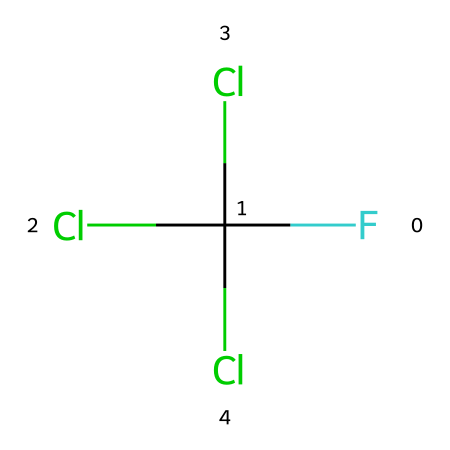What is the total number of chlorine atoms in this molecule? The given SMILES shows three chlorine atoms represented by 'Cl' in the composition. By counting the occurrences, we find three chlorine atoms present.
Answer: three How many fluorine atoms are present in this chemical? In the SMILES notation, there is one occurrence of 'F', indicating that there is one fluorine atom in this compound.
Answer: one What type of chemical is represented by this structure? The presence of fluorine and chlorine atoms, along with a carbon atom suggests this molecule is a chlorofluorocarbon, commonly known as CFC.
Answer: chlorofluorocarbon What is the valency of carbon in this molecule? Carbon typically has four valence electrons and forms four bonds, and in this structure, it is bonded to three chlorine atoms and one fluorine atom, fulfilling its tetravalent nature.
Answer: four Which atoms in the molecule are halogens? Fluorine (F) and chlorine (Cl) are atoms known as halogens; thus, both types of atoms present here, reflected in their chemical symbols in the structure, are halogens.
Answer: fluorine and chlorine How does the presence of chlorine atoms affect the environmental impact of this chemical? Chlorine atoms are known to contribute to ozone depletion by breaking down ozone molecules in the atmosphere, leading to significant environmental concerns.
Answer: ozone depletion 